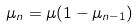<formula> <loc_0><loc_0><loc_500><loc_500>\mu _ { n } = \mu ( 1 - \mu _ { n - 1 } )</formula> 